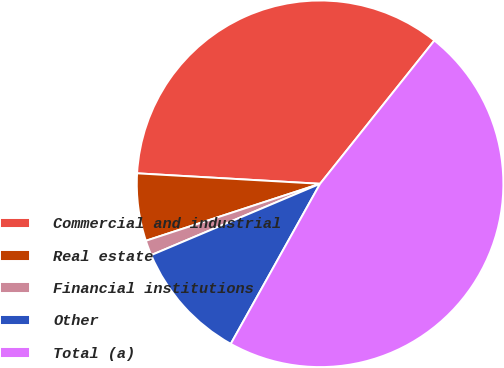Convert chart. <chart><loc_0><loc_0><loc_500><loc_500><pie_chart><fcel>Commercial and industrial<fcel>Real estate<fcel>Financial institutions<fcel>Other<fcel>Total (a)<nl><fcel>34.81%<fcel>5.94%<fcel>1.33%<fcel>10.54%<fcel>47.39%<nl></chart> 